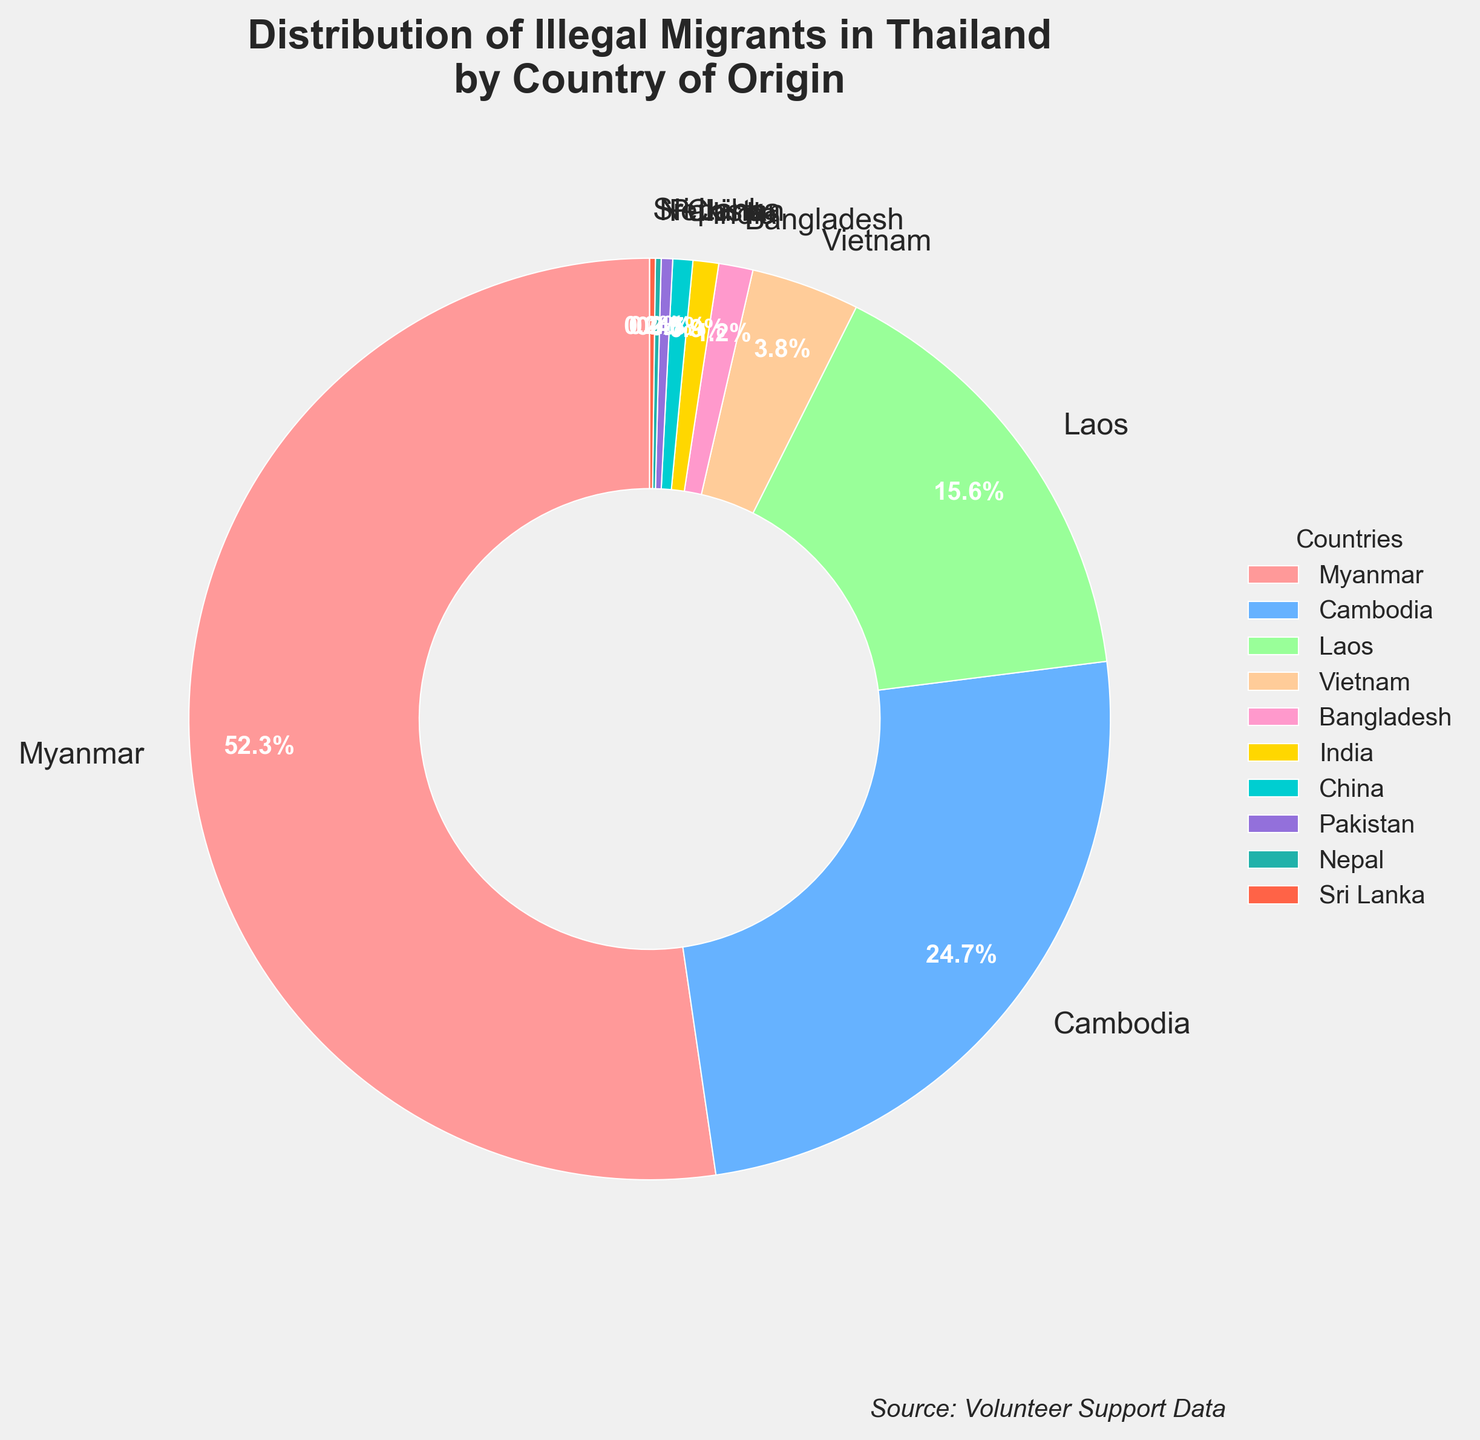Which country has the highest percentage of illegal migrants in Thailand? The figure shows that Myanmar has the largest slice of the pie chart, which indicates the highest percentage.
Answer: Myanmar What is the combined percentage of illegal migrants from Laos and Cambodia? According to the figure, the percentage for Laos is 15.6% and for Cambodia is 24.7%. Adding these two percentages together gives 15.6% + 24.7% = 40.3%.
Answer: 40.3% How many countries contribute to less than 1% of the illegal migrants? The percentages for Bangladesh, India, China, Pakistan, Nepal, and Sri Lanka are all less than 1%. Counting these countries gives us a total of 6 countries.
Answer: 6 Is the percentage of illegal migrants from Vietnam greater than or less than that from Laos? The figure indicates that Vietnam has 3.8% while Laos has 15.6%. Thus, Vietnam's percentage is much less than Laos's percentage.
Answer: Less What proportion of the illegal migrants come from countries other than Myanmar, Cambodia, and Laos? To find this, we need to subtract the combined percentage of Myanmar, Cambodia, and Laos from the total 100%. Myanmar (52.3%) + Cambodia (24.7%) + Laos (15.6%) = 92.6%. Therefore, the other countries contribute 100% - 92.6% = 7.4%.
Answer: 7.4% Which color represents the segment for Cambodia, and what is its percentage? The color corresponding to the segment for Cambodia is blue, and its percentage is 24.7%.
Answer: Blue, 24.7% Compare the percentages of illegal migrants from Nepal and Pakistan. Which is higher? Referring to the figure, Nepal has a percentage of 0.2% and Pakistan has 0.4%. Therefore, Pakistan has a higher percentage than Nepal.
Answer: Pakistan What is the difference in percentage between illegal migrants from Bangladesh and India? The percentage for Bangladesh is 1.2% and for India is 0.9%. Subtracting these gives 1.2% - 0.9% = 0.3%.
Answer: 0.3% How does the percentage of illegal migrants from Vietnam compare to the sum of those from Bangladesh, India, and China? Adding the percentages for Bangladesh (1.2%), India (0.9%), and China (0.7%) gives 1.2% + 0.9% + 0.7% = 2.8%. Since Vietnam's percentage is 3.8%, it is greater than the combined total of Bangladesh, India, and China.
Answer: Greater Which countries combined account for approximately one-fourth of the illegal migrant population? Cambodia has a percentage of 24.7%, which is very close to one-fourth (25%) of the total population.
Answer: Cambodia 